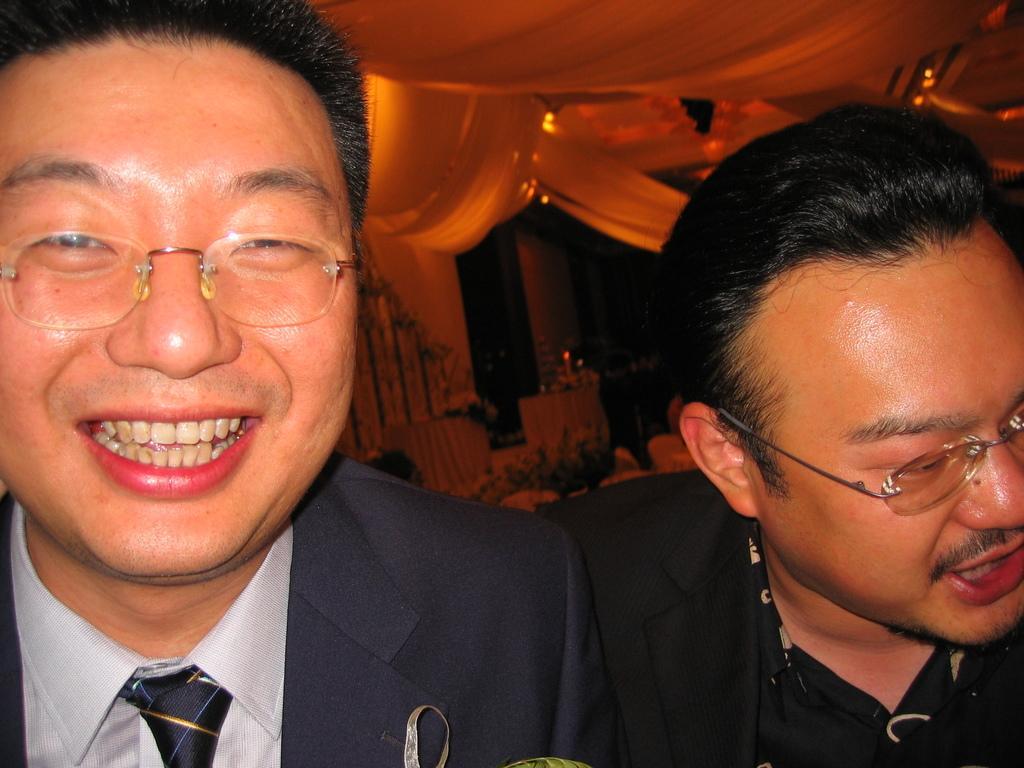How would you summarize this image in a sentence or two? In this image I can see two persons. In the background there are some objects. 